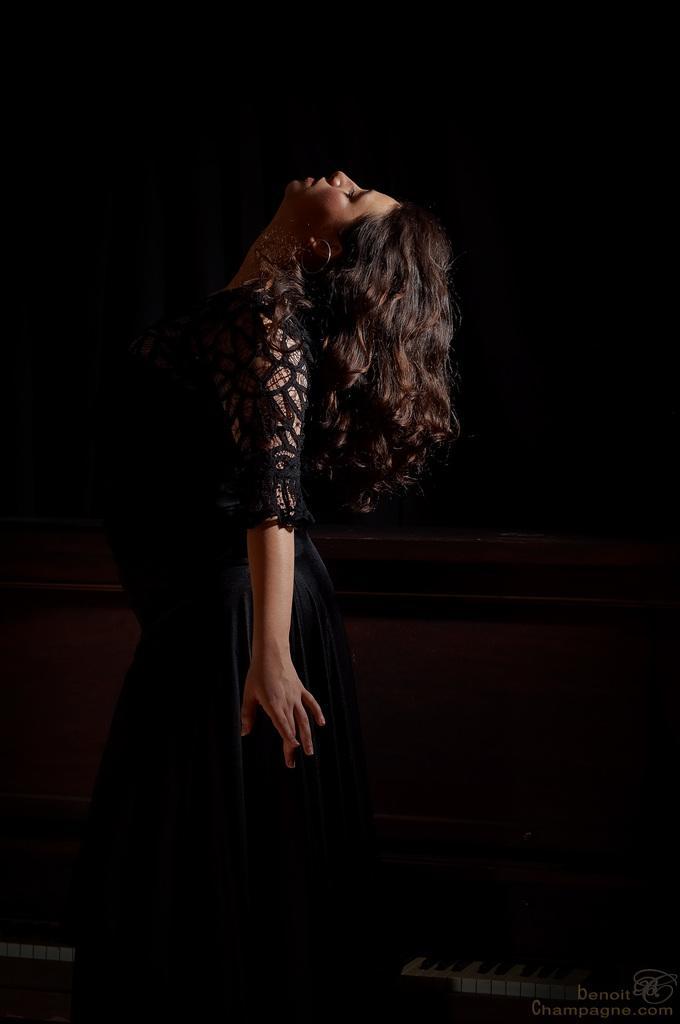Please provide a concise description of this image. In this image we can see a lady is wearing black color dress and standing. In the background of the image is dark. 